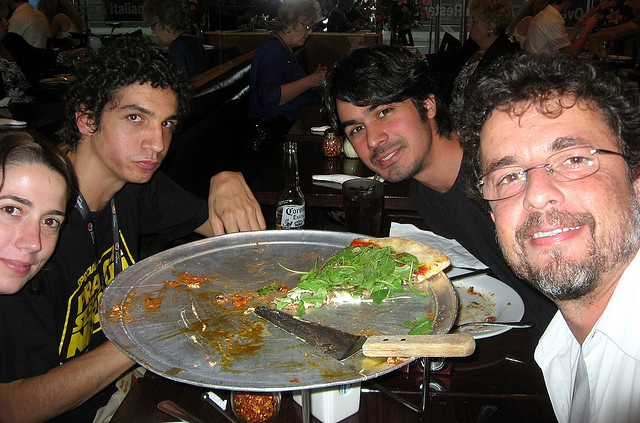Describe the objects in this image and their specific colors. I can see dining table in black, gray, darkgray, and olive tones, people in black, salmon, white, and gray tones, people in black, gray, and maroon tones, people in black, brown, and maroon tones, and people in black, lightpink, and gray tones in this image. 